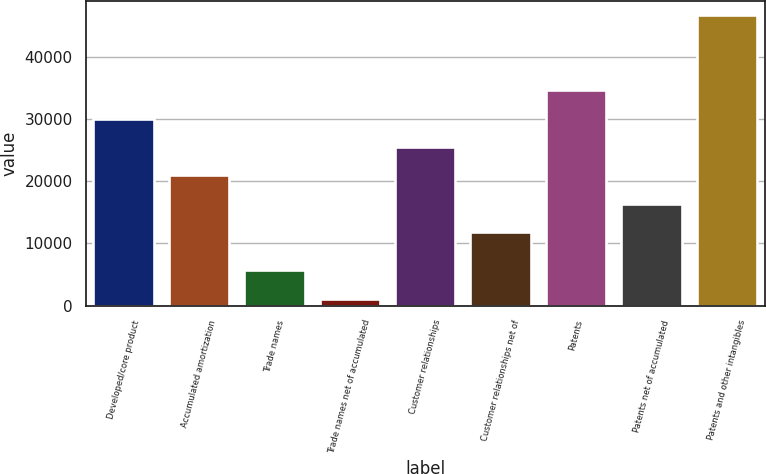Convert chart. <chart><loc_0><loc_0><loc_500><loc_500><bar_chart><fcel>Developed/core product<fcel>Accumulated amortization<fcel>Trade names<fcel>Trade names net of accumulated<fcel>Customer relationships<fcel>Customer relationships net of<fcel>Patents<fcel>Patents net of accumulated<fcel>Patents and other intangibles<nl><fcel>30117.6<fcel>20990.8<fcel>5700.4<fcel>1137<fcel>25554.2<fcel>11864<fcel>34681<fcel>16427.4<fcel>46771<nl></chart> 